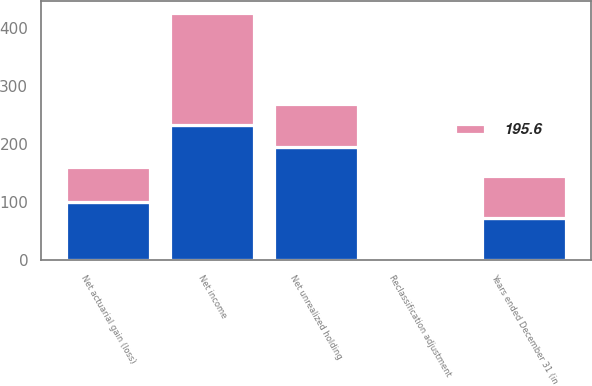Convert chart to OTSL. <chart><loc_0><loc_0><loc_500><loc_500><stacked_bar_chart><ecel><fcel>Years ended December 31 (in<fcel>Net income<fcel>Net actuarial gain (loss)<fcel>Reclassification adjustment<fcel>Net unrealized holding<nl><fcel>nan<fcel>72.5<fcel>232.4<fcel>99.7<fcel>1.1<fcel>194.4<nl><fcel>195.6<fcel>72.5<fcel>192.4<fcel>60.3<fcel>2.1<fcel>74.6<nl></chart> 